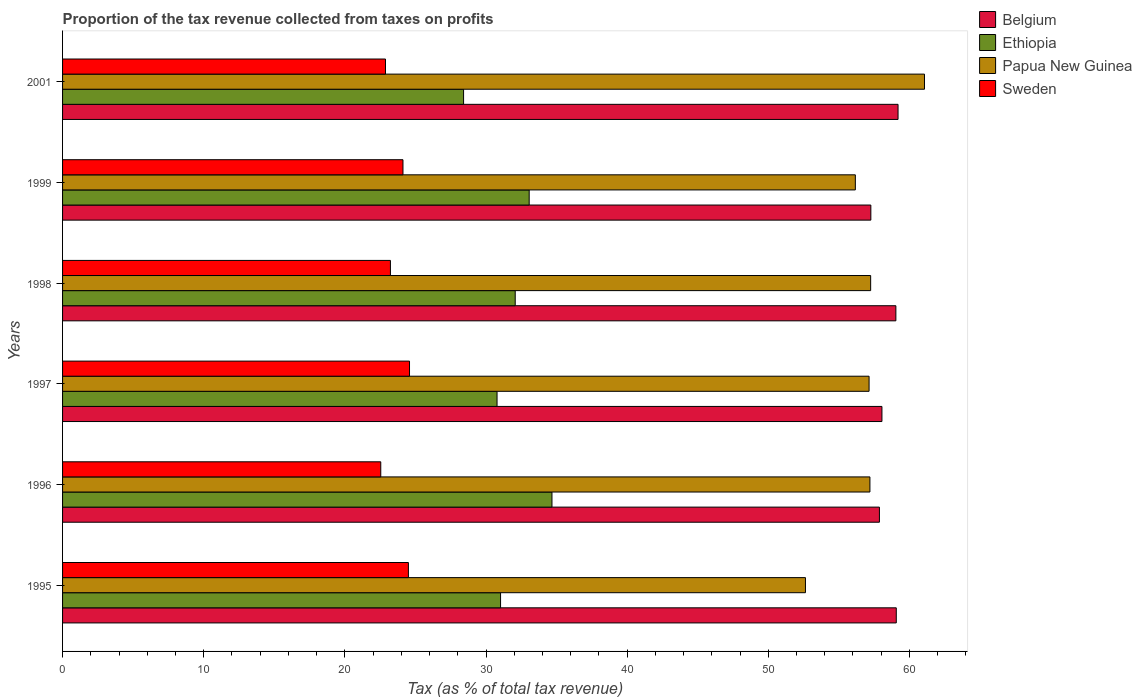How many groups of bars are there?
Offer a very short reply. 6. What is the proportion of the tax revenue collected in Papua New Guinea in 1996?
Ensure brevity in your answer.  57.2. Across all years, what is the maximum proportion of the tax revenue collected in Ethiopia?
Ensure brevity in your answer.  34.67. Across all years, what is the minimum proportion of the tax revenue collected in Belgium?
Offer a terse response. 57.27. In which year was the proportion of the tax revenue collected in Ethiopia maximum?
Your answer should be very brief. 1996. What is the total proportion of the tax revenue collected in Belgium in the graph?
Provide a succinct answer. 350.49. What is the difference between the proportion of the tax revenue collected in Belgium in 1999 and that in 2001?
Provide a succinct answer. -1.93. What is the difference between the proportion of the tax revenue collected in Belgium in 1998 and the proportion of the tax revenue collected in Papua New Guinea in 2001?
Ensure brevity in your answer.  -2.03. What is the average proportion of the tax revenue collected in Ethiopia per year?
Offer a very short reply. 31.67. In the year 1995, what is the difference between the proportion of the tax revenue collected in Sweden and proportion of the tax revenue collected in Papua New Guinea?
Provide a short and direct response. -28.13. In how many years, is the proportion of the tax revenue collected in Papua New Guinea greater than 16 %?
Make the answer very short. 6. What is the ratio of the proportion of the tax revenue collected in Belgium in 1996 to that in 2001?
Your answer should be very brief. 0.98. Is the difference between the proportion of the tax revenue collected in Sweden in 1999 and 2001 greater than the difference between the proportion of the tax revenue collected in Papua New Guinea in 1999 and 2001?
Make the answer very short. Yes. What is the difference between the highest and the second highest proportion of the tax revenue collected in Ethiopia?
Offer a terse response. 1.61. What is the difference between the highest and the lowest proportion of the tax revenue collected in Belgium?
Make the answer very short. 1.93. In how many years, is the proportion of the tax revenue collected in Ethiopia greater than the average proportion of the tax revenue collected in Ethiopia taken over all years?
Provide a succinct answer. 3. Is the sum of the proportion of the tax revenue collected in Sweden in 1998 and 2001 greater than the maximum proportion of the tax revenue collected in Ethiopia across all years?
Keep it short and to the point. Yes. What does the 3rd bar from the top in 2001 represents?
Your answer should be compact. Ethiopia. What does the 2nd bar from the bottom in 1998 represents?
Ensure brevity in your answer.  Ethiopia. How many bars are there?
Provide a short and direct response. 24. How many years are there in the graph?
Keep it short and to the point. 6. Are the values on the major ticks of X-axis written in scientific E-notation?
Make the answer very short. No. Does the graph contain grids?
Ensure brevity in your answer.  No. How are the legend labels stacked?
Provide a succinct answer. Vertical. What is the title of the graph?
Your answer should be very brief. Proportion of the tax revenue collected from taxes on profits. What is the label or title of the X-axis?
Your response must be concise. Tax (as % of total tax revenue). What is the Tax (as % of total tax revenue) of Belgium in 1995?
Provide a short and direct response. 59.07. What is the Tax (as % of total tax revenue) in Ethiopia in 1995?
Provide a short and direct response. 31.03. What is the Tax (as % of total tax revenue) of Papua New Guinea in 1995?
Your answer should be compact. 52.63. What is the Tax (as % of total tax revenue) in Sweden in 1995?
Provide a succinct answer. 24.5. What is the Tax (as % of total tax revenue) in Belgium in 1996?
Provide a short and direct response. 57.87. What is the Tax (as % of total tax revenue) in Ethiopia in 1996?
Your answer should be very brief. 34.67. What is the Tax (as % of total tax revenue) of Papua New Guinea in 1996?
Provide a succinct answer. 57.2. What is the Tax (as % of total tax revenue) of Sweden in 1996?
Ensure brevity in your answer.  22.54. What is the Tax (as % of total tax revenue) in Belgium in 1997?
Give a very brief answer. 58.05. What is the Tax (as % of total tax revenue) in Ethiopia in 1997?
Provide a short and direct response. 30.78. What is the Tax (as % of total tax revenue) of Papua New Guinea in 1997?
Offer a terse response. 57.14. What is the Tax (as % of total tax revenue) in Sweden in 1997?
Make the answer very short. 24.58. What is the Tax (as % of total tax revenue) in Belgium in 1998?
Offer a very short reply. 59.04. What is the Tax (as % of total tax revenue) in Ethiopia in 1998?
Your response must be concise. 32.07. What is the Tax (as % of total tax revenue) in Papua New Guinea in 1998?
Your answer should be compact. 57.25. What is the Tax (as % of total tax revenue) of Sweden in 1998?
Offer a very short reply. 23.23. What is the Tax (as % of total tax revenue) of Belgium in 1999?
Give a very brief answer. 57.27. What is the Tax (as % of total tax revenue) in Ethiopia in 1999?
Keep it short and to the point. 33.06. What is the Tax (as % of total tax revenue) of Papua New Guinea in 1999?
Your response must be concise. 56.17. What is the Tax (as % of total tax revenue) of Sweden in 1999?
Your answer should be compact. 24.12. What is the Tax (as % of total tax revenue) of Belgium in 2001?
Your answer should be compact. 59.19. What is the Tax (as % of total tax revenue) of Ethiopia in 2001?
Your answer should be compact. 28.41. What is the Tax (as % of total tax revenue) of Papua New Guinea in 2001?
Offer a terse response. 61.07. What is the Tax (as % of total tax revenue) of Sweden in 2001?
Keep it short and to the point. 22.88. Across all years, what is the maximum Tax (as % of total tax revenue) of Belgium?
Give a very brief answer. 59.19. Across all years, what is the maximum Tax (as % of total tax revenue) in Ethiopia?
Your answer should be compact. 34.67. Across all years, what is the maximum Tax (as % of total tax revenue) in Papua New Guinea?
Give a very brief answer. 61.07. Across all years, what is the maximum Tax (as % of total tax revenue) of Sweden?
Provide a succinct answer. 24.58. Across all years, what is the minimum Tax (as % of total tax revenue) of Belgium?
Offer a very short reply. 57.27. Across all years, what is the minimum Tax (as % of total tax revenue) in Ethiopia?
Offer a very short reply. 28.41. Across all years, what is the minimum Tax (as % of total tax revenue) of Papua New Guinea?
Your response must be concise. 52.63. Across all years, what is the minimum Tax (as % of total tax revenue) of Sweden?
Provide a short and direct response. 22.54. What is the total Tax (as % of total tax revenue) in Belgium in the graph?
Give a very brief answer. 350.49. What is the total Tax (as % of total tax revenue) in Ethiopia in the graph?
Offer a very short reply. 190.03. What is the total Tax (as % of total tax revenue) of Papua New Guinea in the graph?
Provide a succinct answer. 341.46. What is the total Tax (as % of total tax revenue) in Sweden in the graph?
Ensure brevity in your answer.  141.85. What is the difference between the Tax (as % of total tax revenue) of Belgium in 1995 and that in 1996?
Your answer should be very brief. 1.19. What is the difference between the Tax (as % of total tax revenue) in Ethiopia in 1995 and that in 1996?
Offer a very short reply. -3.64. What is the difference between the Tax (as % of total tax revenue) in Papua New Guinea in 1995 and that in 1996?
Your answer should be compact. -4.57. What is the difference between the Tax (as % of total tax revenue) of Sweden in 1995 and that in 1996?
Your answer should be very brief. 1.96. What is the difference between the Tax (as % of total tax revenue) in Belgium in 1995 and that in 1997?
Offer a very short reply. 1.02. What is the difference between the Tax (as % of total tax revenue) of Ethiopia in 1995 and that in 1997?
Make the answer very short. 0.25. What is the difference between the Tax (as % of total tax revenue) of Papua New Guinea in 1995 and that in 1997?
Provide a succinct answer. -4.51. What is the difference between the Tax (as % of total tax revenue) in Sweden in 1995 and that in 1997?
Your answer should be compact. -0.08. What is the difference between the Tax (as % of total tax revenue) of Belgium in 1995 and that in 1998?
Your answer should be compact. 0.03. What is the difference between the Tax (as % of total tax revenue) in Ethiopia in 1995 and that in 1998?
Ensure brevity in your answer.  -1.04. What is the difference between the Tax (as % of total tax revenue) of Papua New Guinea in 1995 and that in 1998?
Your answer should be compact. -4.62. What is the difference between the Tax (as % of total tax revenue) in Sweden in 1995 and that in 1998?
Offer a terse response. 1.27. What is the difference between the Tax (as % of total tax revenue) of Belgium in 1995 and that in 1999?
Make the answer very short. 1.8. What is the difference between the Tax (as % of total tax revenue) in Ethiopia in 1995 and that in 1999?
Offer a terse response. -2.03. What is the difference between the Tax (as % of total tax revenue) of Papua New Guinea in 1995 and that in 1999?
Make the answer very short. -3.53. What is the difference between the Tax (as % of total tax revenue) in Sweden in 1995 and that in 1999?
Provide a short and direct response. 0.39. What is the difference between the Tax (as % of total tax revenue) of Belgium in 1995 and that in 2001?
Your answer should be compact. -0.13. What is the difference between the Tax (as % of total tax revenue) in Ethiopia in 1995 and that in 2001?
Keep it short and to the point. 2.62. What is the difference between the Tax (as % of total tax revenue) of Papua New Guinea in 1995 and that in 2001?
Offer a terse response. -8.43. What is the difference between the Tax (as % of total tax revenue) of Sweden in 1995 and that in 2001?
Provide a short and direct response. 1.62. What is the difference between the Tax (as % of total tax revenue) of Belgium in 1996 and that in 1997?
Ensure brevity in your answer.  -0.18. What is the difference between the Tax (as % of total tax revenue) in Ethiopia in 1996 and that in 1997?
Offer a very short reply. 3.89. What is the difference between the Tax (as % of total tax revenue) of Papua New Guinea in 1996 and that in 1997?
Provide a succinct answer. 0.06. What is the difference between the Tax (as % of total tax revenue) in Sweden in 1996 and that in 1997?
Provide a short and direct response. -2.04. What is the difference between the Tax (as % of total tax revenue) of Belgium in 1996 and that in 1998?
Provide a succinct answer. -1.17. What is the difference between the Tax (as % of total tax revenue) in Ethiopia in 1996 and that in 1998?
Your response must be concise. 2.6. What is the difference between the Tax (as % of total tax revenue) in Papua New Guinea in 1996 and that in 1998?
Provide a short and direct response. -0.05. What is the difference between the Tax (as % of total tax revenue) in Sweden in 1996 and that in 1998?
Provide a short and direct response. -0.68. What is the difference between the Tax (as % of total tax revenue) of Belgium in 1996 and that in 1999?
Provide a short and direct response. 0.61. What is the difference between the Tax (as % of total tax revenue) in Ethiopia in 1996 and that in 1999?
Give a very brief answer. 1.61. What is the difference between the Tax (as % of total tax revenue) in Papua New Guinea in 1996 and that in 1999?
Keep it short and to the point. 1.03. What is the difference between the Tax (as % of total tax revenue) of Sweden in 1996 and that in 1999?
Keep it short and to the point. -1.57. What is the difference between the Tax (as % of total tax revenue) in Belgium in 1996 and that in 2001?
Provide a succinct answer. -1.32. What is the difference between the Tax (as % of total tax revenue) in Ethiopia in 1996 and that in 2001?
Provide a succinct answer. 6.26. What is the difference between the Tax (as % of total tax revenue) of Papua New Guinea in 1996 and that in 2001?
Offer a very short reply. -3.87. What is the difference between the Tax (as % of total tax revenue) of Sweden in 1996 and that in 2001?
Give a very brief answer. -0.34. What is the difference between the Tax (as % of total tax revenue) in Belgium in 1997 and that in 1998?
Offer a terse response. -0.99. What is the difference between the Tax (as % of total tax revenue) of Ethiopia in 1997 and that in 1998?
Make the answer very short. -1.29. What is the difference between the Tax (as % of total tax revenue) in Papua New Guinea in 1997 and that in 1998?
Provide a short and direct response. -0.11. What is the difference between the Tax (as % of total tax revenue) of Sweden in 1997 and that in 1998?
Keep it short and to the point. 1.35. What is the difference between the Tax (as % of total tax revenue) of Belgium in 1997 and that in 1999?
Your response must be concise. 0.79. What is the difference between the Tax (as % of total tax revenue) of Ethiopia in 1997 and that in 1999?
Provide a succinct answer. -2.28. What is the difference between the Tax (as % of total tax revenue) of Papua New Guinea in 1997 and that in 1999?
Keep it short and to the point. 0.97. What is the difference between the Tax (as % of total tax revenue) in Sweden in 1997 and that in 1999?
Ensure brevity in your answer.  0.46. What is the difference between the Tax (as % of total tax revenue) of Belgium in 1997 and that in 2001?
Keep it short and to the point. -1.14. What is the difference between the Tax (as % of total tax revenue) in Ethiopia in 1997 and that in 2001?
Provide a succinct answer. 2.37. What is the difference between the Tax (as % of total tax revenue) in Papua New Guinea in 1997 and that in 2001?
Give a very brief answer. -3.93. What is the difference between the Tax (as % of total tax revenue) of Sweden in 1997 and that in 2001?
Make the answer very short. 1.7. What is the difference between the Tax (as % of total tax revenue) of Belgium in 1998 and that in 1999?
Keep it short and to the point. 1.77. What is the difference between the Tax (as % of total tax revenue) in Ethiopia in 1998 and that in 1999?
Your answer should be compact. -0.99. What is the difference between the Tax (as % of total tax revenue) in Papua New Guinea in 1998 and that in 1999?
Provide a succinct answer. 1.09. What is the difference between the Tax (as % of total tax revenue) in Sweden in 1998 and that in 1999?
Your response must be concise. -0.89. What is the difference between the Tax (as % of total tax revenue) in Belgium in 1998 and that in 2001?
Provide a short and direct response. -0.15. What is the difference between the Tax (as % of total tax revenue) in Ethiopia in 1998 and that in 2001?
Offer a terse response. 3.66. What is the difference between the Tax (as % of total tax revenue) in Papua New Guinea in 1998 and that in 2001?
Give a very brief answer. -3.81. What is the difference between the Tax (as % of total tax revenue) in Sweden in 1998 and that in 2001?
Provide a short and direct response. 0.35. What is the difference between the Tax (as % of total tax revenue) of Belgium in 1999 and that in 2001?
Make the answer very short. -1.93. What is the difference between the Tax (as % of total tax revenue) of Ethiopia in 1999 and that in 2001?
Provide a short and direct response. 4.65. What is the difference between the Tax (as % of total tax revenue) in Papua New Guinea in 1999 and that in 2001?
Your response must be concise. -4.9. What is the difference between the Tax (as % of total tax revenue) in Sweden in 1999 and that in 2001?
Your answer should be very brief. 1.24. What is the difference between the Tax (as % of total tax revenue) in Belgium in 1995 and the Tax (as % of total tax revenue) in Ethiopia in 1996?
Your answer should be very brief. 24.39. What is the difference between the Tax (as % of total tax revenue) in Belgium in 1995 and the Tax (as % of total tax revenue) in Papua New Guinea in 1996?
Offer a terse response. 1.87. What is the difference between the Tax (as % of total tax revenue) of Belgium in 1995 and the Tax (as % of total tax revenue) of Sweden in 1996?
Provide a short and direct response. 36.52. What is the difference between the Tax (as % of total tax revenue) of Ethiopia in 1995 and the Tax (as % of total tax revenue) of Papua New Guinea in 1996?
Give a very brief answer. -26.17. What is the difference between the Tax (as % of total tax revenue) of Ethiopia in 1995 and the Tax (as % of total tax revenue) of Sweden in 1996?
Provide a succinct answer. 8.49. What is the difference between the Tax (as % of total tax revenue) of Papua New Guinea in 1995 and the Tax (as % of total tax revenue) of Sweden in 1996?
Give a very brief answer. 30.09. What is the difference between the Tax (as % of total tax revenue) of Belgium in 1995 and the Tax (as % of total tax revenue) of Ethiopia in 1997?
Your answer should be very brief. 28.29. What is the difference between the Tax (as % of total tax revenue) of Belgium in 1995 and the Tax (as % of total tax revenue) of Papua New Guinea in 1997?
Provide a succinct answer. 1.93. What is the difference between the Tax (as % of total tax revenue) of Belgium in 1995 and the Tax (as % of total tax revenue) of Sweden in 1997?
Offer a terse response. 34.49. What is the difference between the Tax (as % of total tax revenue) in Ethiopia in 1995 and the Tax (as % of total tax revenue) in Papua New Guinea in 1997?
Ensure brevity in your answer.  -26.11. What is the difference between the Tax (as % of total tax revenue) in Ethiopia in 1995 and the Tax (as % of total tax revenue) in Sweden in 1997?
Your answer should be very brief. 6.45. What is the difference between the Tax (as % of total tax revenue) in Papua New Guinea in 1995 and the Tax (as % of total tax revenue) in Sweden in 1997?
Your answer should be compact. 28.05. What is the difference between the Tax (as % of total tax revenue) in Belgium in 1995 and the Tax (as % of total tax revenue) in Ethiopia in 1998?
Your answer should be compact. 27. What is the difference between the Tax (as % of total tax revenue) of Belgium in 1995 and the Tax (as % of total tax revenue) of Papua New Guinea in 1998?
Give a very brief answer. 1.82. What is the difference between the Tax (as % of total tax revenue) of Belgium in 1995 and the Tax (as % of total tax revenue) of Sweden in 1998?
Provide a short and direct response. 35.84. What is the difference between the Tax (as % of total tax revenue) in Ethiopia in 1995 and the Tax (as % of total tax revenue) in Papua New Guinea in 1998?
Your answer should be very brief. -26.22. What is the difference between the Tax (as % of total tax revenue) of Ethiopia in 1995 and the Tax (as % of total tax revenue) of Sweden in 1998?
Give a very brief answer. 7.8. What is the difference between the Tax (as % of total tax revenue) of Papua New Guinea in 1995 and the Tax (as % of total tax revenue) of Sweden in 1998?
Make the answer very short. 29.41. What is the difference between the Tax (as % of total tax revenue) in Belgium in 1995 and the Tax (as % of total tax revenue) in Ethiopia in 1999?
Offer a very short reply. 26.01. What is the difference between the Tax (as % of total tax revenue) of Belgium in 1995 and the Tax (as % of total tax revenue) of Papua New Guinea in 1999?
Your response must be concise. 2.9. What is the difference between the Tax (as % of total tax revenue) in Belgium in 1995 and the Tax (as % of total tax revenue) in Sweden in 1999?
Keep it short and to the point. 34.95. What is the difference between the Tax (as % of total tax revenue) in Ethiopia in 1995 and the Tax (as % of total tax revenue) in Papua New Guinea in 1999?
Your response must be concise. -25.14. What is the difference between the Tax (as % of total tax revenue) of Ethiopia in 1995 and the Tax (as % of total tax revenue) of Sweden in 1999?
Your answer should be compact. 6.91. What is the difference between the Tax (as % of total tax revenue) of Papua New Guinea in 1995 and the Tax (as % of total tax revenue) of Sweden in 1999?
Ensure brevity in your answer.  28.52. What is the difference between the Tax (as % of total tax revenue) of Belgium in 1995 and the Tax (as % of total tax revenue) of Ethiopia in 2001?
Give a very brief answer. 30.66. What is the difference between the Tax (as % of total tax revenue) of Belgium in 1995 and the Tax (as % of total tax revenue) of Papua New Guinea in 2001?
Give a very brief answer. -2. What is the difference between the Tax (as % of total tax revenue) in Belgium in 1995 and the Tax (as % of total tax revenue) in Sweden in 2001?
Your response must be concise. 36.19. What is the difference between the Tax (as % of total tax revenue) of Ethiopia in 1995 and the Tax (as % of total tax revenue) of Papua New Guinea in 2001?
Make the answer very short. -30.04. What is the difference between the Tax (as % of total tax revenue) of Ethiopia in 1995 and the Tax (as % of total tax revenue) of Sweden in 2001?
Your answer should be very brief. 8.15. What is the difference between the Tax (as % of total tax revenue) of Papua New Guinea in 1995 and the Tax (as % of total tax revenue) of Sweden in 2001?
Offer a very short reply. 29.75. What is the difference between the Tax (as % of total tax revenue) in Belgium in 1996 and the Tax (as % of total tax revenue) in Ethiopia in 1997?
Make the answer very short. 27.09. What is the difference between the Tax (as % of total tax revenue) in Belgium in 1996 and the Tax (as % of total tax revenue) in Papua New Guinea in 1997?
Offer a terse response. 0.73. What is the difference between the Tax (as % of total tax revenue) of Belgium in 1996 and the Tax (as % of total tax revenue) of Sweden in 1997?
Offer a very short reply. 33.29. What is the difference between the Tax (as % of total tax revenue) in Ethiopia in 1996 and the Tax (as % of total tax revenue) in Papua New Guinea in 1997?
Ensure brevity in your answer.  -22.47. What is the difference between the Tax (as % of total tax revenue) of Ethiopia in 1996 and the Tax (as % of total tax revenue) of Sweden in 1997?
Keep it short and to the point. 10.09. What is the difference between the Tax (as % of total tax revenue) in Papua New Guinea in 1996 and the Tax (as % of total tax revenue) in Sweden in 1997?
Keep it short and to the point. 32.62. What is the difference between the Tax (as % of total tax revenue) in Belgium in 1996 and the Tax (as % of total tax revenue) in Ethiopia in 1998?
Keep it short and to the point. 25.8. What is the difference between the Tax (as % of total tax revenue) of Belgium in 1996 and the Tax (as % of total tax revenue) of Papua New Guinea in 1998?
Ensure brevity in your answer.  0.62. What is the difference between the Tax (as % of total tax revenue) of Belgium in 1996 and the Tax (as % of total tax revenue) of Sweden in 1998?
Your answer should be very brief. 34.65. What is the difference between the Tax (as % of total tax revenue) in Ethiopia in 1996 and the Tax (as % of total tax revenue) in Papua New Guinea in 1998?
Your answer should be compact. -22.58. What is the difference between the Tax (as % of total tax revenue) in Ethiopia in 1996 and the Tax (as % of total tax revenue) in Sweden in 1998?
Offer a very short reply. 11.45. What is the difference between the Tax (as % of total tax revenue) in Papua New Guinea in 1996 and the Tax (as % of total tax revenue) in Sweden in 1998?
Keep it short and to the point. 33.97. What is the difference between the Tax (as % of total tax revenue) in Belgium in 1996 and the Tax (as % of total tax revenue) in Ethiopia in 1999?
Ensure brevity in your answer.  24.81. What is the difference between the Tax (as % of total tax revenue) of Belgium in 1996 and the Tax (as % of total tax revenue) of Papua New Guinea in 1999?
Offer a very short reply. 1.71. What is the difference between the Tax (as % of total tax revenue) in Belgium in 1996 and the Tax (as % of total tax revenue) in Sweden in 1999?
Keep it short and to the point. 33.76. What is the difference between the Tax (as % of total tax revenue) in Ethiopia in 1996 and the Tax (as % of total tax revenue) in Papua New Guinea in 1999?
Your answer should be very brief. -21.49. What is the difference between the Tax (as % of total tax revenue) of Ethiopia in 1996 and the Tax (as % of total tax revenue) of Sweden in 1999?
Your answer should be very brief. 10.56. What is the difference between the Tax (as % of total tax revenue) in Papua New Guinea in 1996 and the Tax (as % of total tax revenue) in Sweden in 1999?
Give a very brief answer. 33.08. What is the difference between the Tax (as % of total tax revenue) in Belgium in 1996 and the Tax (as % of total tax revenue) in Ethiopia in 2001?
Give a very brief answer. 29.46. What is the difference between the Tax (as % of total tax revenue) in Belgium in 1996 and the Tax (as % of total tax revenue) in Papua New Guinea in 2001?
Make the answer very short. -3.19. What is the difference between the Tax (as % of total tax revenue) in Belgium in 1996 and the Tax (as % of total tax revenue) in Sweden in 2001?
Make the answer very short. 34.99. What is the difference between the Tax (as % of total tax revenue) of Ethiopia in 1996 and the Tax (as % of total tax revenue) of Papua New Guinea in 2001?
Ensure brevity in your answer.  -26.39. What is the difference between the Tax (as % of total tax revenue) in Ethiopia in 1996 and the Tax (as % of total tax revenue) in Sweden in 2001?
Your answer should be compact. 11.79. What is the difference between the Tax (as % of total tax revenue) in Papua New Guinea in 1996 and the Tax (as % of total tax revenue) in Sweden in 2001?
Offer a very short reply. 34.32. What is the difference between the Tax (as % of total tax revenue) of Belgium in 1997 and the Tax (as % of total tax revenue) of Ethiopia in 1998?
Ensure brevity in your answer.  25.98. What is the difference between the Tax (as % of total tax revenue) of Belgium in 1997 and the Tax (as % of total tax revenue) of Papua New Guinea in 1998?
Keep it short and to the point. 0.8. What is the difference between the Tax (as % of total tax revenue) of Belgium in 1997 and the Tax (as % of total tax revenue) of Sweden in 1998?
Provide a succinct answer. 34.82. What is the difference between the Tax (as % of total tax revenue) in Ethiopia in 1997 and the Tax (as % of total tax revenue) in Papua New Guinea in 1998?
Give a very brief answer. -26.47. What is the difference between the Tax (as % of total tax revenue) of Ethiopia in 1997 and the Tax (as % of total tax revenue) of Sweden in 1998?
Provide a short and direct response. 7.55. What is the difference between the Tax (as % of total tax revenue) of Papua New Guinea in 1997 and the Tax (as % of total tax revenue) of Sweden in 1998?
Make the answer very short. 33.91. What is the difference between the Tax (as % of total tax revenue) in Belgium in 1997 and the Tax (as % of total tax revenue) in Ethiopia in 1999?
Your answer should be compact. 24.99. What is the difference between the Tax (as % of total tax revenue) of Belgium in 1997 and the Tax (as % of total tax revenue) of Papua New Guinea in 1999?
Give a very brief answer. 1.88. What is the difference between the Tax (as % of total tax revenue) in Belgium in 1997 and the Tax (as % of total tax revenue) in Sweden in 1999?
Offer a very short reply. 33.93. What is the difference between the Tax (as % of total tax revenue) in Ethiopia in 1997 and the Tax (as % of total tax revenue) in Papua New Guinea in 1999?
Your response must be concise. -25.38. What is the difference between the Tax (as % of total tax revenue) in Ethiopia in 1997 and the Tax (as % of total tax revenue) in Sweden in 1999?
Your answer should be compact. 6.67. What is the difference between the Tax (as % of total tax revenue) of Papua New Guinea in 1997 and the Tax (as % of total tax revenue) of Sweden in 1999?
Ensure brevity in your answer.  33.02. What is the difference between the Tax (as % of total tax revenue) of Belgium in 1997 and the Tax (as % of total tax revenue) of Ethiopia in 2001?
Your answer should be very brief. 29.64. What is the difference between the Tax (as % of total tax revenue) of Belgium in 1997 and the Tax (as % of total tax revenue) of Papua New Guinea in 2001?
Your answer should be compact. -3.02. What is the difference between the Tax (as % of total tax revenue) in Belgium in 1997 and the Tax (as % of total tax revenue) in Sweden in 2001?
Ensure brevity in your answer.  35.17. What is the difference between the Tax (as % of total tax revenue) of Ethiopia in 1997 and the Tax (as % of total tax revenue) of Papua New Guinea in 2001?
Your answer should be very brief. -30.28. What is the difference between the Tax (as % of total tax revenue) in Ethiopia in 1997 and the Tax (as % of total tax revenue) in Sweden in 2001?
Your response must be concise. 7.9. What is the difference between the Tax (as % of total tax revenue) of Papua New Guinea in 1997 and the Tax (as % of total tax revenue) of Sweden in 2001?
Your answer should be compact. 34.26. What is the difference between the Tax (as % of total tax revenue) of Belgium in 1998 and the Tax (as % of total tax revenue) of Ethiopia in 1999?
Your answer should be compact. 25.98. What is the difference between the Tax (as % of total tax revenue) of Belgium in 1998 and the Tax (as % of total tax revenue) of Papua New Guinea in 1999?
Your answer should be compact. 2.87. What is the difference between the Tax (as % of total tax revenue) in Belgium in 1998 and the Tax (as % of total tax revenue) in Sweden in 1999?
Provide a short and direct response. 34.92. What is the difference between the Tax (as % of total tax revenue) of Ethiopia in 1998 and the Tax (as % of total tax revenue) of Papua New Guinea in 1999?
Your response must be concise. -24.1. What is the difference between the Tax (as % of total tax revenue) in Ethiopia in 1998 and the Tax (as % of total tax revenue) in Sweden in 1999?
Provide a short and direct response. 7.95. What is the difference between the Tax (as % of total tax revenue) in Papua New Guinea in 1998 and the Tax (as % of total tax revenue) in Sweden in 1999?
Your response must be concise. 33.14. What is the difference between the Tax (as % of total tax revenue) in Belgium in 1998 and the Tax (as % of total tax revenue) in Ethiopia in 2001?
Your answer should be compact. 30.63. What is the difference between the Tax (as % of total tax revenue) of Belgium in 1998 and the Tax (as % of total tax revenue) of Papua New Guinea in 2001?
Offer a terse response. -2.03. What is the difference between the Tax (as % of total tax revenue) of Belgium in 1998 and the Tax (as % of total tax revenue) of Sweden in 2001?
Your answer should be compact. 36.16. What is the difference between the Tax (as % of total tax revenue) in Ethiopia in 1998 and the Tax (as % of total tax revenue) in Papua New Guinea in 2001?
Offer a very short reply. -29. What is the difference between the Tax (as % of total tax revenue) in Ethiopia in 1998 and the Tax (as % of total tax revenue) in Sweden in 2001?
Your answer should be very brief. 9.19. What is the difference between the Tax (as % of total tax revenue) of Papua New Guinea in 1998 and the Tax (as % of total tax revenue) of Sweden in 2001?
Keep it short and to the point. 34.37. What is the difference between the Tax (as % of total tax revenue) of Belgium in 1999 and the Tax (as % of total tax revenue) of Ethiopia in 2001?
Provide a succinct answer. 28.85. What is the difference between the Tax (as % of total tax revenue) of Belgium in 1999 and the Tax (as % of total tax revenue) of Papua New Guinea in 2001?
Offer a terse response. -3.8. What is the difference between the Tax (as % of total tax revenue) of Belgium in 1999 and the Tax (as % of total tax revenue) of Sweden in 2001?
Provide a short and direct response. 34.39. What is the difference between the Tax (as % of total tax revenue) in Ethiopia in 1999 and the Tax (as % of total tax revenue) in Papua New Guinea in 2001?
Offer a very short reply. -28.01. What is the difference between the Tax (as % of total tax revenue) of Ethiopia in 1999 and the Tax (as % of total tax revenue) of Sweden in 2001?
Provide a short and direct response. 10.18. What is the difference between the Tax (as % of total tax revenue) in Papua New Guinea in 1999 and the Tax (as % of total tax revenue) in Sweden in 2001?
Make the answer very short. 33.29. What is the average Tax (as % of total tax revenue) of Belgium per year?
Give a very brief answer. 58.42. What is the average Tax (as % of total tax revenue) of Ethiopia per year?
Provide a succinct answer. 31.67. What is the average Tax (as % of total tax revenue) of Papua New Guinea per year?
Offer a terse response. 56.91. What is the average Tax (as % of total tax revenue) of Sweden per year?
Offer a terse response. 23.64. In the year 1995, what is the difference between the Tax (as % of total tax revenue) of Belgium and Tax (as % of total tax revenue) of Ethiopia?
Provide a short and direct response. 28.04. In the year 1995, what is the difference between the Tax (as % of total tax revenue) in Belgium and Tax (as % of total tax revenue) in Papua New Guinea?
Offer a very short reply. 6.43. In the year 1995, what is the difference between the Tax (as % of total tax revenue) in Belgium and Tax (as % of total tax revenue) in Sweden?
Ensure brevity in your answer.  34.56. In the year 1995, what is the difference between the Tax (as % of total tax revenue) of Ethiopia and Tax (as % of total tax revenue) of Papua New Guinea?
Your response must be concise. -21.6. In the year 1995, what is the difference between the Tax (as % of total tax revenue) in Ethiopia and Tax (as % of total tax revenue) in Sweden?
Your answer should be compact. 6.53. In the year 1995, what is the difference between the Tax (as % of total tax revenue) of Papua New Guinea and Tax (as % of total tax revenue) of Sweden?
Offer a very short reply. 28.13. In the year 1996, what is the difference between the Tax (as % of total tax revenue) in Belgium and Tax (as % of total tax revenue) in Ethiopia?
Offer a terse response. 23.2. In the year 1996, what is the difference between the Tax (as % of total tax revenue) in Belgium and Tax (as % of total tax revenue) in Papua New Guinea?
Your answer should be very brief. 0.67. In the year 1996, what is the difference between the Tax (as % of total tax revenue) in Belgium and Tax (as % of total tax revenue) in Sweden?
Offer a very short reply. 35.33. In the year 1996, what is the difference between the Tax (as % of total tax revenue) of Ethiopia and Tax (as % of total tax revenue) of Papua New Guinea?
Provide a succinct answer. -22.53. In the year 1996, what is the difference between the Tax (as % of total tax revenue) in Ethiopia and Tax (as % of total tax revenue) in Sweden?
Make the answer very short. 12.13. In the year 1996, what is the difference between the Tax (as % of total tax revenue) of Papua New Guinea and Tax (as % of total tax revenue) of Sweden?
Offer a very short reply. 34.66. In the year 1997, what is the difference between the Tax (as % of total tax revenue) in Belgium and Tax (as % of total tax revenue) in Ethiopia?
Give a very brief answer. 27.27. In the year 1997, what is the difference between the Tax (as % of total tax revenue) in Belgium and Tax (as % of total tax revenue) in Papua New Guinea?
Offer a terse response. 0.91. In the year 1997, what is the difference between the Tax (as % of total tax revenue) of Belgium and Tax (as % of total tax revenue) of Sweden?
Your response must be concise. 33.47. In the year 1997, what is the difference between the Tax (as % of total tax revenue) in Ethiopia and Tax (as % of total tax revenue) in Papua New Guinea?
Give a very brief answer. -26.36. In the year 1997, what is the difference between the Tax (as % of total tax revenue) of Ethiopia and Tax (as % of total tax revenue) of Sweden?
Offer a very short reply. 6.2. In the year 1997, what is the difference between the Tax (as % of total tax revenue) in Papua New Guinea and Tax (as % of total tax revenue) in Sweden?
Your response must be concise. 32.56. In the year 1998, what is the difference between the Tax (as % of total tax revenue) of Belgium and Tax (as % of total tax revenue) of Ethiopia?
Provide a succinct answer. 26.97. In the year 1998, what is the difference between the Tax (as % of total tax revenue) in Belgium and Tax (as % of total tax revenue) in Papua New Guinea?
Your response must be concise. 1.79. In the year 1998, what is the difference between the Tax (as % of total tax revenue) in Belgium and Tax (as % of total tax revenue) in Sweden?
Give a very brief answer. 35.81. In the year 1998, what is the difference between the Tax (as % of total tax revenue) in Ethiopia and Tax (as % of total tax revenue) in Papua New Guinea?
Provide a succinct answer. -25.18. In the year 1998, what is the difference between the Tax (as % of total tax revenue) of Ethiopia and Tax (as % of total tax revenue) of Sweden?
Ensure brevity in your answer.  8.84. In the year 1998, what is the difference between the Tax (as % of total tax revenue) in Papua New Guinea and Tax (as % of total tax revenue) in Sweden?
Give a very brief answer. 34.02. In the year 1999, what is the difference between the Tax (as % of total tax revenue) of Belgium and Tax (as % of total tax revenue) of Ethiopia?
Provide a short and direct response. 24.21. In the year 1999, what is the difference between the Tax (as % of total tax revenue) of Belgium and Tax (as % of total tax revenue) of Papua New Guinea?
Offer a terse response. 1.1. In the year 1999, what is the difference between the Tax (as % of total tax revenue) in Belgium and Tax (as % of total tax revenue) in Sweden?
Keep it short and to the point. 33.15. In the year 1999, what is the difference between the Tax (as % of total tax revenue) of Ethiopia and Tax (as % of total tax revenue) of Papua New Guinea?
Make the answer very short. -23.11. In the year 1999, what is the difference between the Tax (as % of total tax revenue) of Ethiopia and Tax (as % of total tax revenue) of Sweden?
Offer a very short reply. 8.94. In the year 1999, what is the difference between the Tax (as % of total tax revenue) in Papua New Guinea and Tax (as % of total tax revenue) in Sweden?
Your response must be concise. 32.05. In the year 2001, what is the difference between the Tax (as % of total tax revenue) in Belgium and Tax (as % of total tax revenue) in Ethiopia?
Offer a very short reply. 30.78. In the year 2001, what is the difference between the Tax (as % of total tax revenue) in Belgium and Tax (as % of total tax revenue) in Papua New Guinea?
Your answer should be very brief. -1.87. In the year 2001, what is the difference between the Tax (as % of total tax revenue) of Belgium and Tax (as % of total tax revenue) of Sweden?
Give a very brief answer. 36.31. In the year 2001, what is the difference between the Tax (as % of total tax revenue) of Ethiopia and Tax (as % of total tax revenue) of Papua New Guinea?
Make the answer very short. -32.66. In the year 2001, what is the difference between the Tax (as % of total tax revenue) in Ethiopia and Tax (as % of total tax revenue) in Sweden?
Make the answer very short. 5.53. In the year 2001, what is the difference between the Tax (as % of total tax revenue) in Papua New Guinea and Tax (as % of total tax revenue) in Sweden?
Your answer should be very brief. 38.19. What is the ratio of the Tax (as % of total tax revenue) of Belgium in 1995 to that in 1996?
Make the answer very short. 1.02. What is the ratio of the Tax (as % of total tax revenue) in Ethiopia in 1995 to that in 1996?
Your answer should be compact. 0.9. What is the ratio of the Tax (as % of total tax revenue) of Papua New Guinea in 1995 to that in 1996?
Offer a very short reply. 0.92. What is the ratio of the Tax (as % of total tax revenue) in Sweden in 1995 to that in 1996?
Provide a succinct answer. 1.09. What is the ratio of the Tax (as % of total tax revenue) in Belgium in 1995 to that in 1997?
Offer a very short reply. 1.02. What is the ratio of the Tax (as % of total tax revenue) in Papua New Guinea in 1995 to that in 1997?
Your response must be concise. 0.92. What is the ratio of the Tax (as % of total tax revenue) in Sweden in 1995 to that in 1997?
Your answer should be compact. 1. What is the ratio of the Tax (as % of total tax revenue) in Ethiopia in 1995 to that in 1998?
Offer a terse response. 0.97. What is the ratio of the Tax (as % of total tax revenue) of Papua New Guinea in 1995 to that in 1998?
Ensure brevity in your answer.  0.92. What is the ratio of the Tax (as % of total tax revenue) in Sweden in 1995 to that in 1998?
Give a very brief answer. 1.05. What is the ratio of the Tax (as % of total tax revenue) of Belgium in 1995 to that in 1999?
Offer a very short reply. 1.03. What is the ratio of the Tax (as % of total tax revenue) in Ethiopia in 1995 to that in 1999?
Give a very brief answer. 0.94. What is the ratio of the Tax (as % of total tax revenue) of Papua New Guinea in 1995 to that in 1999?
Provide a succinct answer. 0.94. What is the ratio of the Tax (as % of total tax revenue) of Sweden in 1995 to that in 1999?
Provide a short and direct response. 1.02. What is the ratio of the Tax (as % of total tax revenue) of Ethiopia in 1995 to that in 2001?
Provide a succinct answer. 1.09. What is the ratio of the Tax (as % of total tax revenue) in Papua New Guinea in 1995 to that in 2001?
Make the answer very short. 0.86. What is the ratio of the Tax (as % of total tax revenue) in Sweden in 1995 to that in 2001?
Make the answer very short. 1.07. What is the ratio of the Tax (as % of total tax revenue) of Belgium in 1996 to that in 1997?
Your response must be concise. 1. What is the ratio of the Tax (as % of total tax revenue) in Ethiopia in 1996 to that in 1997?
Your answer should be compact. 1.13. What is the ratio of the Tax (as % of total tax revenue) in Sweden in 1996 to that in 1997?
Offer a very short reply. 0.92. What is the ratio of the Tax (as % of total tax revenue) of Belgium in 1996 to that in 1998?
Ensure brevity in your answer.  0.98. What is the ratio of the Tax (as % of total tax revenue) of Ethiopia in 1996 to that in 1998?
Provide a succinct answer. 1.08. What is the ratio of the Tax (as % of total tax revenue) in Papua New Guinea in 1996 to that in 1998?
Offer a terse response. 1. What is the ratio of the Tax (as % of total tax revenue) in Sweden in 1996 to that in 1998?
Give a very brief answer. 0.97. What is the ratio of the Tax (as % of total tax revenue) of Belgium in 1996 to that in 1999?
Your response must be concise. 1.01. What is the ratio of the Tax (as % of total tax revenue) in Ethiopia in 1996 to that in 1999?
Provide a succinct answer. 1.05. What is the ratio of the Tax (as % of total tax revenue) in Papua New Guinea in 1996 to that in 1999?
Ensure brevity in your answer.  1.02. What is the ratio of the Tax (as % of total tax revenue) in Sweden in 1996 to that in 1999?
Offer a very short reply. 0.93. What is the ratio of the Tax (as % of total tax revenue) in Belgium in 1996 to that in 2001?
Provide a succinct answer. 0.98. What is the ratio of the Tax (as % of total tax revenue) in Ethiopia in 1996 to that in 2001?
Provide a succinct answer. 1.22. What is the ratio of the Tax (as % of total tax revenue) in Papua New Guinea in 1996 to that in 2001?
Your answer should be very brief. 0.94. What is the ratio of the Tax (as % of total tax revenue) of Sweden in 1996 to that in 2001?
Ensure brevity in your answer.  0.99. What is the ratio of the Tax (as % of total tax revenue) of Belgium in 1997 to that in 1998?
Provide a succinct answer. 0.98. What is the ratio of the Tax (as % of total tax revenue) of Ethiopia in 1997 to that in 1998?
Provide a short and direct response. 0.96. What is the ratio of the Tax (as % of total tax revenue) of Sweden in 1997 to that in 1998?
Provide a short and direct response. 1.06. What is the ratio of the Tax (as % of total tax revenue) in Belgium in 1997 to that in 1999?
Offer a terse response. 1.01. What is the ratio of the Tax (as % of total tax revenue) in Ethiopia in 1997 to that in 1999?
Provide a short and direct response. 0.93. What is the ratio of the Tax (as % of total tax revenue) in Papua New Guinea in 1997 to that in 1999?
Your answer should be very brief. 1.02. What is the ratio of the Tax (as % of total tax revenue) of Sweden in 1997 to that in 1999?
Keep it short and to the point. 1.02. What is the ratio of the Tax (as % of total tax revenue) in Belgium in 1997 to that in 2001?
Ensure brevity in your answer.  0.98. What is the ratio of the Tax (as % of total tax revenue) in Ethiopia in 1997 to that in 2001?
Offer a very short reply. 1.08. What is the ratio of the Tax (as % of total tax revenue) of Papua New Guinea in 1997 to that in 2001?
Provide a succinct answer. 0.94. What is the ratio of the Tax (as % of total tax revenue) of Sweden in 1997 to that in 2001?
Give a very brief answer. 1.07. What is the ratio of the Tax (as % of total tax revenue) in Belgium in 1998 to that in 1999?
Your response must be concise. 1.03. What is the ratio of the Tax (as % of total tax revenue) in Papua New Guinea in 1998 to that in 1999?
Your answer should be compact. 1.02. What is the ratio of the Tax (as % of total tax revenue) in Sweden in 1998 to that in 1999?
Your response must be concise. 0.96. What is the ratio of the Tax (as % of total tax revenue) of Ethiopia in 1998 to that in 2001?
Offer a terse response. 1.13. What is the ratio of the Tax (as % of total tax revenue) in Sweden in 1998 to that in 2001?
Make the answer very short. 1.02. What is the ratio of the Tax (as % of total tax revenue) of Belgium in 1999 to that in 2001?
Keep it short and to the point. 0.97. What is the ratio of the Tax (as % of total tax revenue) in Ethiopia in 1999 to that in 2001?
Your answer should be very brief. 1.16. What is the ratio of the Tax (as % of total tax revenue) of Papua New Guinea in 1999 to that in 2001?
Keep it short and to the point. 0.92. What is the ratio of the Tax (as % of total tax revenue) in Sweden in 1999 to that in 2001?
Your answer should be very brief. 1.05. What is the difference between the highest and the second highest Tax (as % of total tax revenue) in Belgium?
Provide a short and direct response. 0.13. What is the difference between the highest and the second highest Tax (as % of total tax revenue) in Ethiopia?
Provide a short and direct response. 1.61. What is the difference between the highest and the second highest Tax (as % of total tax revenue) of Papua New Guinea?
Give a very brief answer. 3.81. What is the difference between the highest and the second highest Tax (as % of total tax revenue) in Sweden?
Offer a terse response. 0.08. What is the difference between the highest and the lowest Tax (as % of total tax revenue) in Belgium?
Ensure brevity in your answer.  1.93. What is the difference between the highest and the lowest Tax (as % of total tax revenue) in Ethiopia?
Make the answer very short. 6.26. What is the difference between the highest and the lowest Tax (as % of total tax revenue) of Papua New Guinea?
Ensure brevity in your answer.  8.43. What is the difference between the highest and the lowest Tax (as % of total tax revenue) in Sweden?
Offer a very short reply. 2.04. 